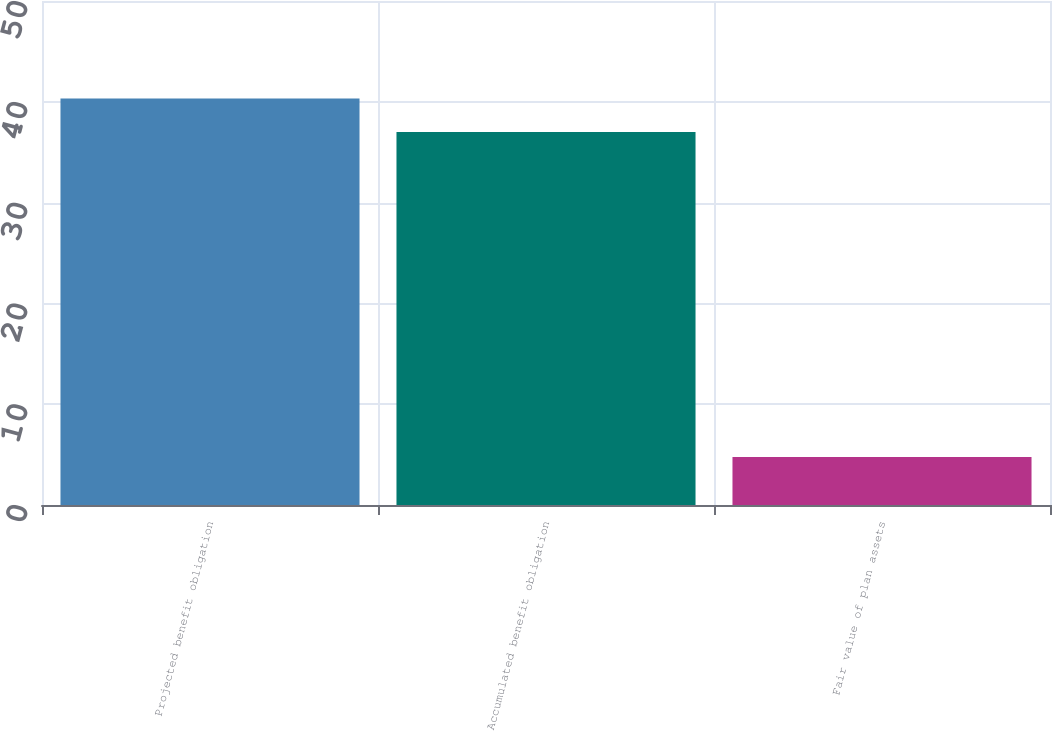Convert chart. <chart><loc_0><loc_0><loc_500><loc_500><bar_chart><fcel>Projected benefit obligation<fcel>Accumulated benefit obligation<fcel>Fair value of plan assets<nl><fcel>40.32<fcel>37<fcel>4.76<nl></chart> 